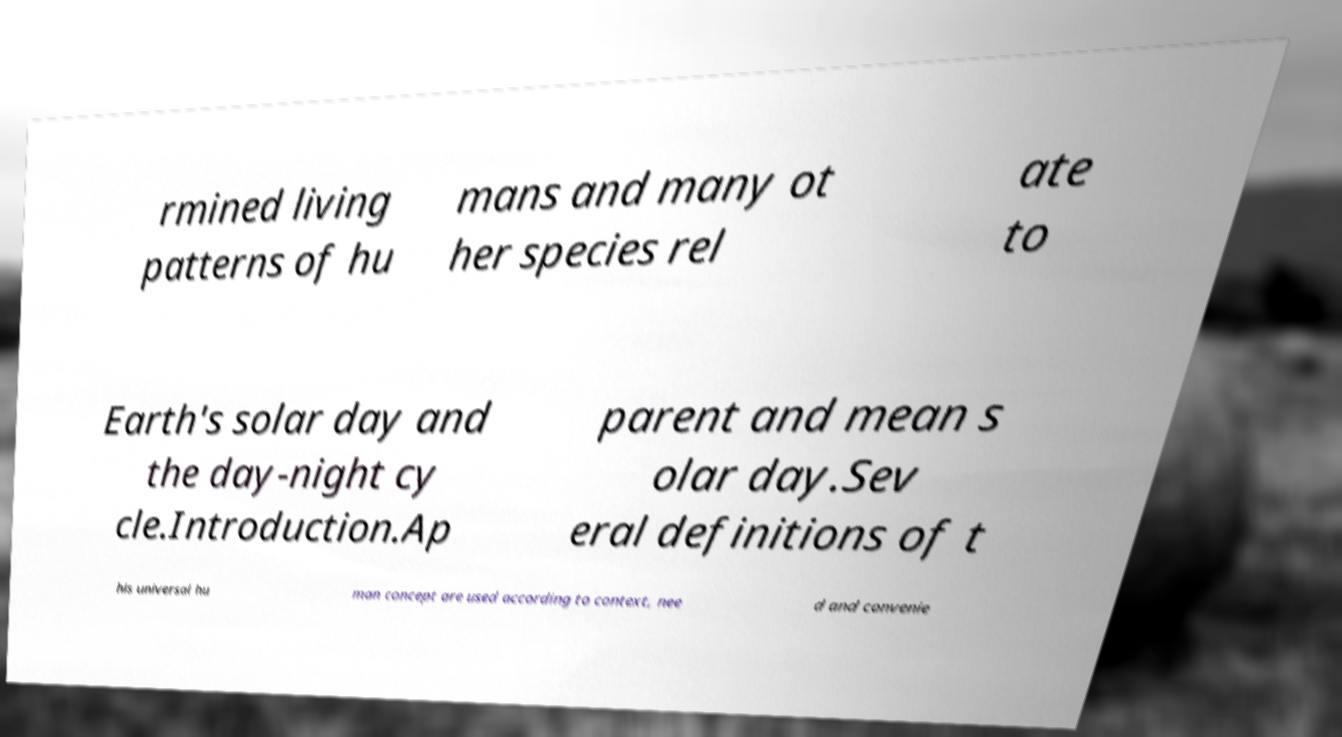Please identify and transcribe the text found in this image. rmined living patterns of hu mans and many ot her species rel ate to Earth's solar day and the day-night cy cle.Introduction.Ap parent and mean s olar day.Sev eral definitions of t his universal hu man concept are used according to context, nee d and convenie 